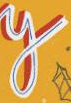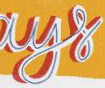What text is displayed in these images sequentially, separated by a semicolon? y; ays 